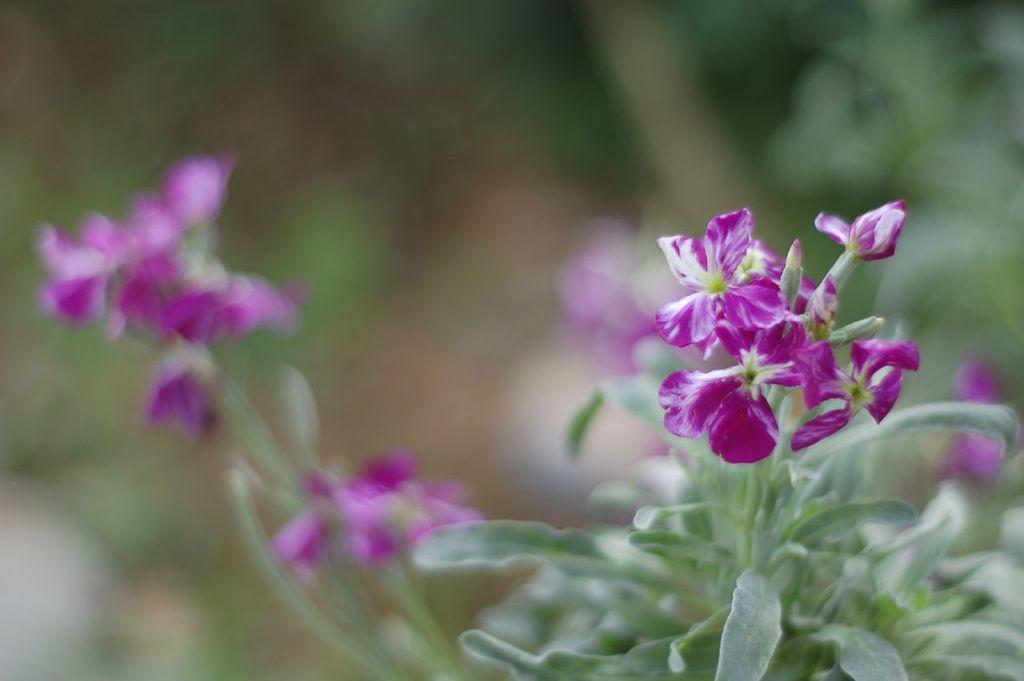Could you give a brief overview of what you see in this image? In the foreground of this image, there are pink flowers to the plants and also few flowers to the plants and the background is blurred. 